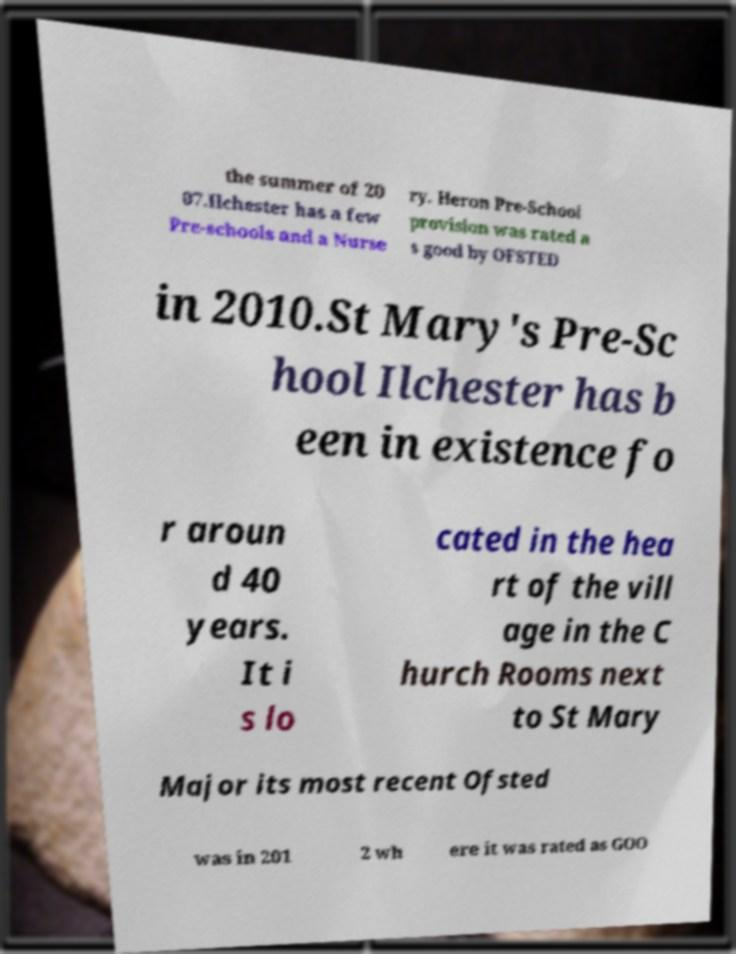Please read and relay the text visible in this image. What does it say? the summer of 20 07.Ilchester has a few Pre-schools and a Nurse ry. Heron Pre-School provision was rated a s good by OFSTED in 2010.St Mary's Pre-Sc hool Ilchester has b een in existence fo r aroun d 40 years. It i s lo cated in the hea rt of the vill age in the C hurch Rooms next to St Mary Major its most recent Ofsted was in 201 2 wh ere it was rated as GOO 